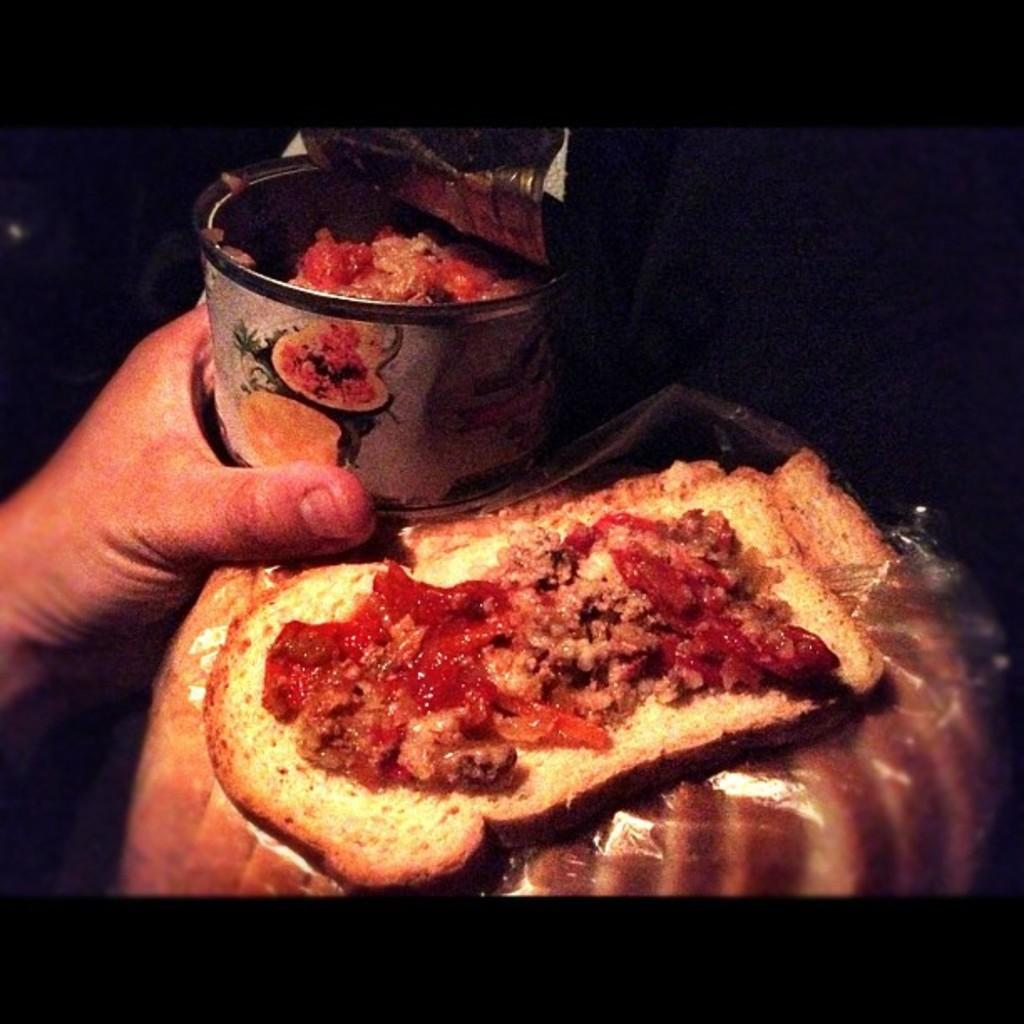Who or what is the main subject in the image? There is a person in the image. What is the person holding in the image? The person's hand is holding a jar. What else can be seen in the image besides the person and the jar? There are food items in the image. Can you describe the background of the image? The background of the image is dark. What type of argument is the person having with the jar in the image? There is no argument present in the image; the person is simply holding a jar. How many letters are visible on the person's nose in the image? There are no letters visible on the person's nose in the image. 